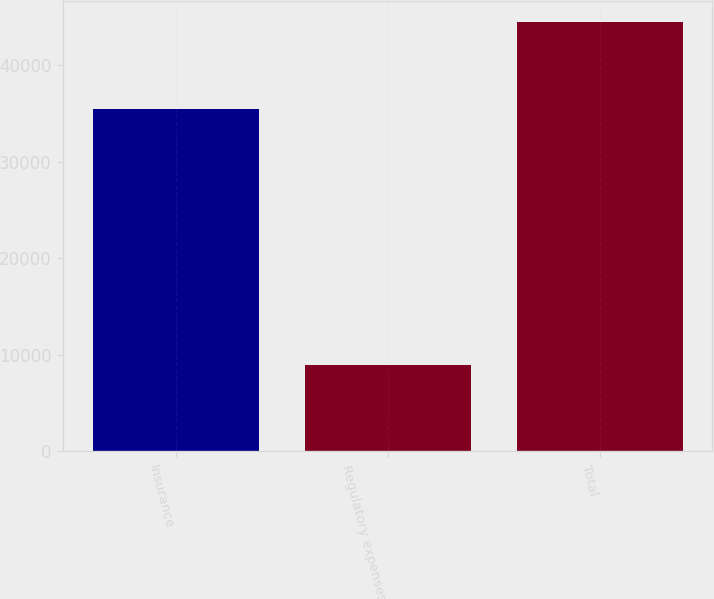Convert chart. <chart><loc_0><loc_0><loc_500><loc_500><bar_chart><fcel>Insurance<fcel>Regulatory expenses<fcel>Total<nl><fcel>35406<fcel>8987<fcel>44393<nl></chart> 